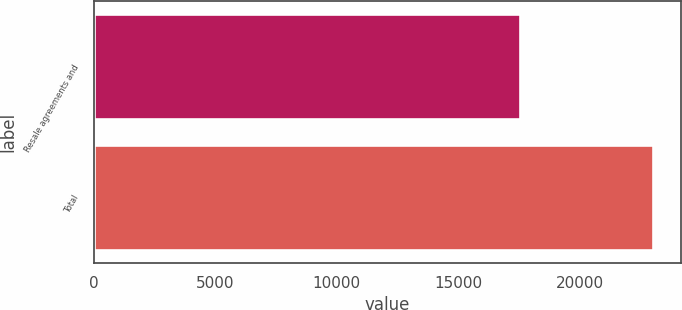Convert chart to OTSL. <chart><loc_0><loc_0><loc_500><loc_500><bar_chart><fcel>Resale agreements and<fcel>Total<nl><fcel>17521<fcel>22997<nl></chart> 